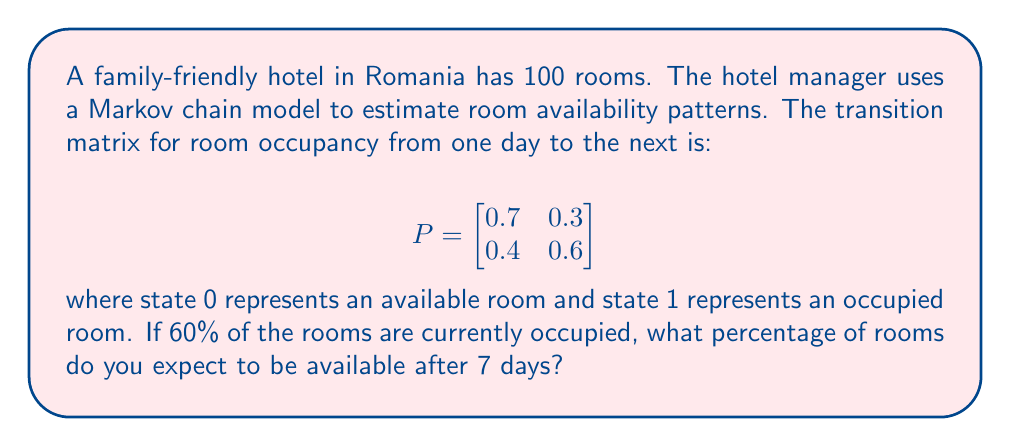Can you solve this math problem? To solve this problem, we'll use spectral decomposition of the transition matrix and calculate the state of the system after 7 days.

Step 1: Find the eigenvalues and eigenvectors of P.
The characteristic equation is:
$$(0.7-\lambda)(0.6-\lambda) - 0.12 = \lambda^2 - 1.3\lambda + 0.3 = 0$$

Solving this equation gives us:
$\lambda_1 = 1$ and $\lambda_2 = 0.3$

The corresponding eigenvectors are:
$$v_1 = \begin{bmatrix} 4/7 \\ 3/7 \end{bmatrix} \text{ and } v_2 = \begin{bmatrix} 1 \\ -1 \end{bmatrix}$$

Step 2: Express $P^7$ using spectral decomposition.
$$P^7 = S\Lambda^7S^{-1}$$
where $S = [v_1 \; v_2]$ and $\Lambda = \text{diag}(1, 0.3)$

$$S = \begin{bmatrix} 4/7 & 1 \\ 3/7 & -1 \end{bmatrix}, \; S^{-1} = \begin{bmatrix} 7/4 & 7/4 \\ 3/4 & -1/4 \end{bmatrix}$$

$$\Lambda^7 = \begin{bmatrix} 1 & 0 \\ 0 & 0.3^7 \end{bmatrix}$$

Step 3: Calculate $P^7$.
$$P^7 = \begin{bmatrix} 4/7 & 1 \\ 3/7 & -1 \end{bmatrix} \begin{bmatrix} 1 & 0 \\ 0 & 0.3^7 \end{bmatrix} \begin{bmatrix} 7/4 & 7/4 \\ 3/4 & -1/4 \end{bmatrix}$$

After multiplication:
$$P^7 \approx \begin{bmatrix} 0.5714 & 0.4286 \\ 0.4286 & 0.5714 \end{bmatrix}$$

Step 4: Calculate the state after 7 days.
Initial state: $x_0 = [0.4 \; 0.6]^T$ (40% available, 60% occupied)
State after 7 days: $x_7 = P^7x_0$

$$x_7 \approx \begin{bmatrix} 0.5714 & 0.4286 \\ 0.4286 & 0.5714 \end{bmatrix} \begin{bmatrix} 0.4 \\ 0.6 \end{bmatrix} \approx \begin{bmatrix} 0.4857 \\ 0.5143 \end{bmatrix}$$

Therefore, after 7 days, approximately 48.57% of rooms are expected to be available.
Answer: 48.57% 